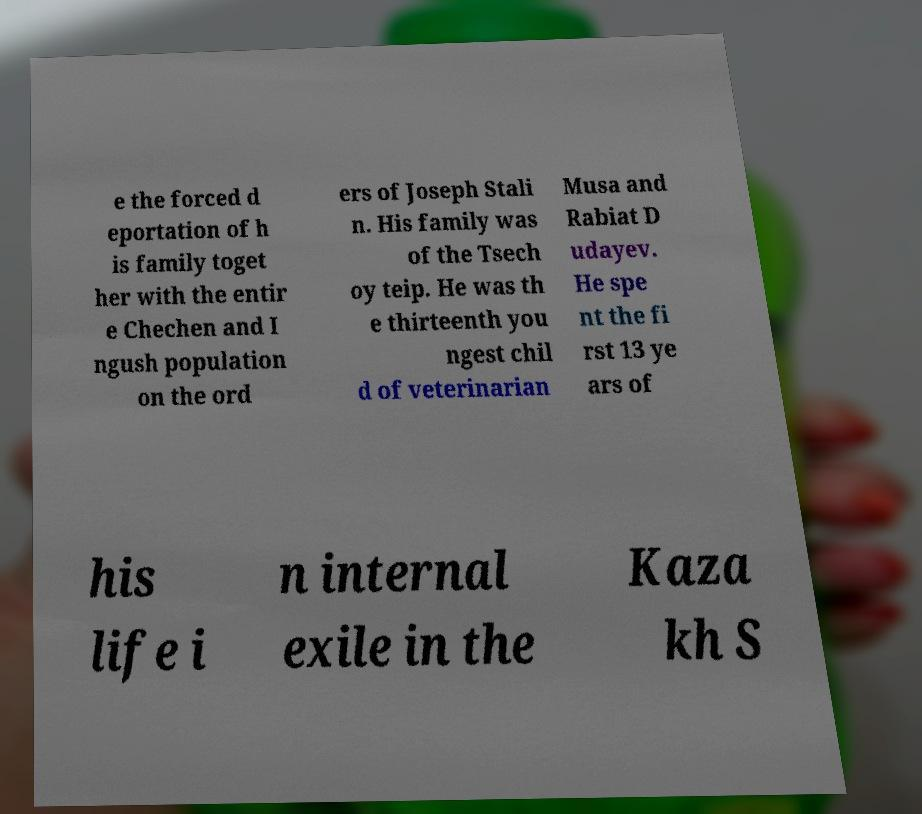Could you extract and type out the text from this image? e the forced d eportation of h is family toget her with the entir e Chechen and I ngush population on the ord ers of Joseph Stali n. His family was of the Tsech oy teip. He was th e thirteenth you ngest chil d of veterinarian Musa and Rabiat D udayev. He spe nt the fi rst 13 ye ars of his life i n internal exile in the Kaza kh S 